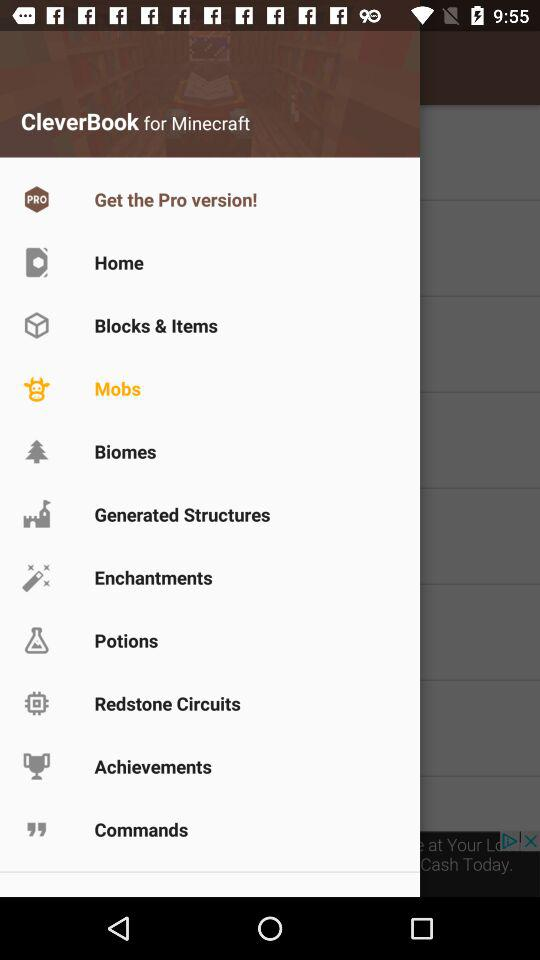How many notifications are there in "Potions"?
When the provided information is insufficient, respond with <no answer>. <no answer> 